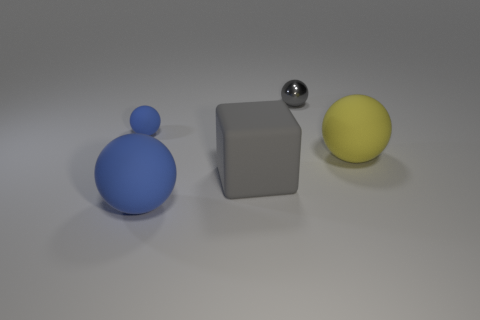Subtract all blue balls. How many balls are left? 2 Subtract all large blue rubber balls. How many balls are left? 3 Subtract 1 blocks. How many blocks are left? 0 Subtract all blocks. How many objects are left? 4 Add 5 gray rubber cubes. How many objects exist? 10 Subtract 0 brown blocks. How many objects are left? 5 Subtract all cyan spheres. Subtract all red blocks. How many spheres are left? 4 Subtract all green cubes. How many yellow spheres are left? 1 Subtract all large blue objects. Subtract all tiny gray spheres. How many objects are left? 3 Add 2 large gray cubes. How many large gray cubes are left? 3 